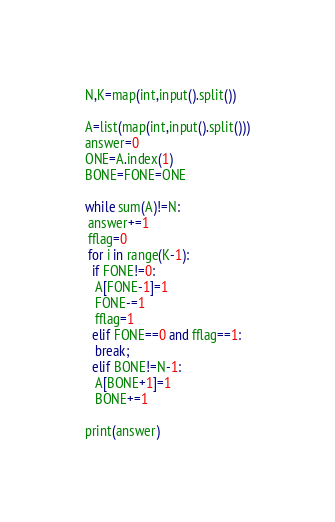Convert code to text. <code><loc_0><loc_0><loc_500><loc_500><_Python_>N,K=map(int,input().split())

A=list(map(int,input().split()))
answer=0
ONE=A.index(1)
BONE=FONE=ONE

while sum(A)!=N:
 answer+=1
 fflag=0
 for i in range(K-1):
  if FONE!=0:
   A[FONE-1]=1
   FONE-=1
   fflag=1
  elif FONE==0 and fflag==1:
   break;
  elif BONE!=N-1:
   A[BONE+1]=1
   BONE+=1

print(answer)</code> 